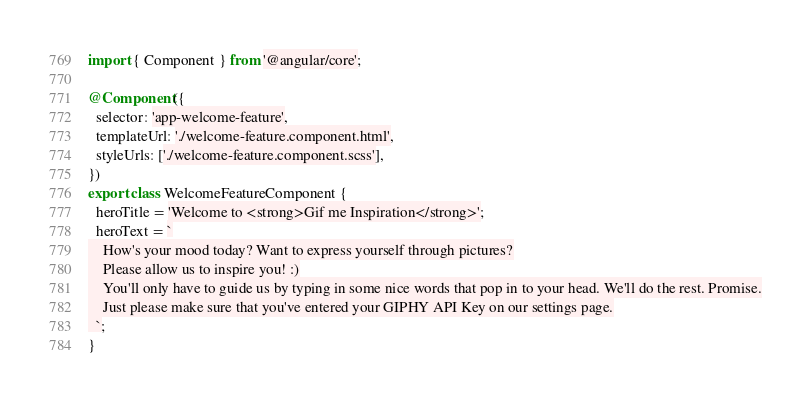<code> <loc_0><loc_0><loc_500><loc_500><_TypeScript_>import { Component } from '@angular/core';

@Component({
  selector: 'app-welcome-feature',
  templateUrl: './welcome-feature.component.html',
  styleUrls: ['./welcome-feature.component.scss'],
})
export class WelcomeFeatureComponent {
  heroTitle = 'Welcome to <strong>Gif me Inspiration</strong>';
  heroText = `
    How's your mood today? Want to express yourself through pictures?
    Please allow us to inspire you! :)
    You'll only have to guide us by typing in some nice words that pop in to your head. We'll do the rest. Promise.
    Just please make sure that you've entered your GIPHY API Key on our settings page.
  `;
}
</code> 